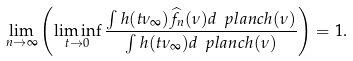Convert formula to latex. <formula><loc_0><loc_0><loc_500><loc_500>\lim _ { n \rightarrow \infty } \left ( \liminf _ { t \rightarrow 0 } \frac { \int h ( t \nu _ { \infty } ) \widehat { f _ { n } } ( \nu ) d \ p l a n c h ( \nu ) } { \int h ( t \nu _ { \infty } ) d \ p l a n c h ( \nu ) } \right ) = 1 .</formula> 